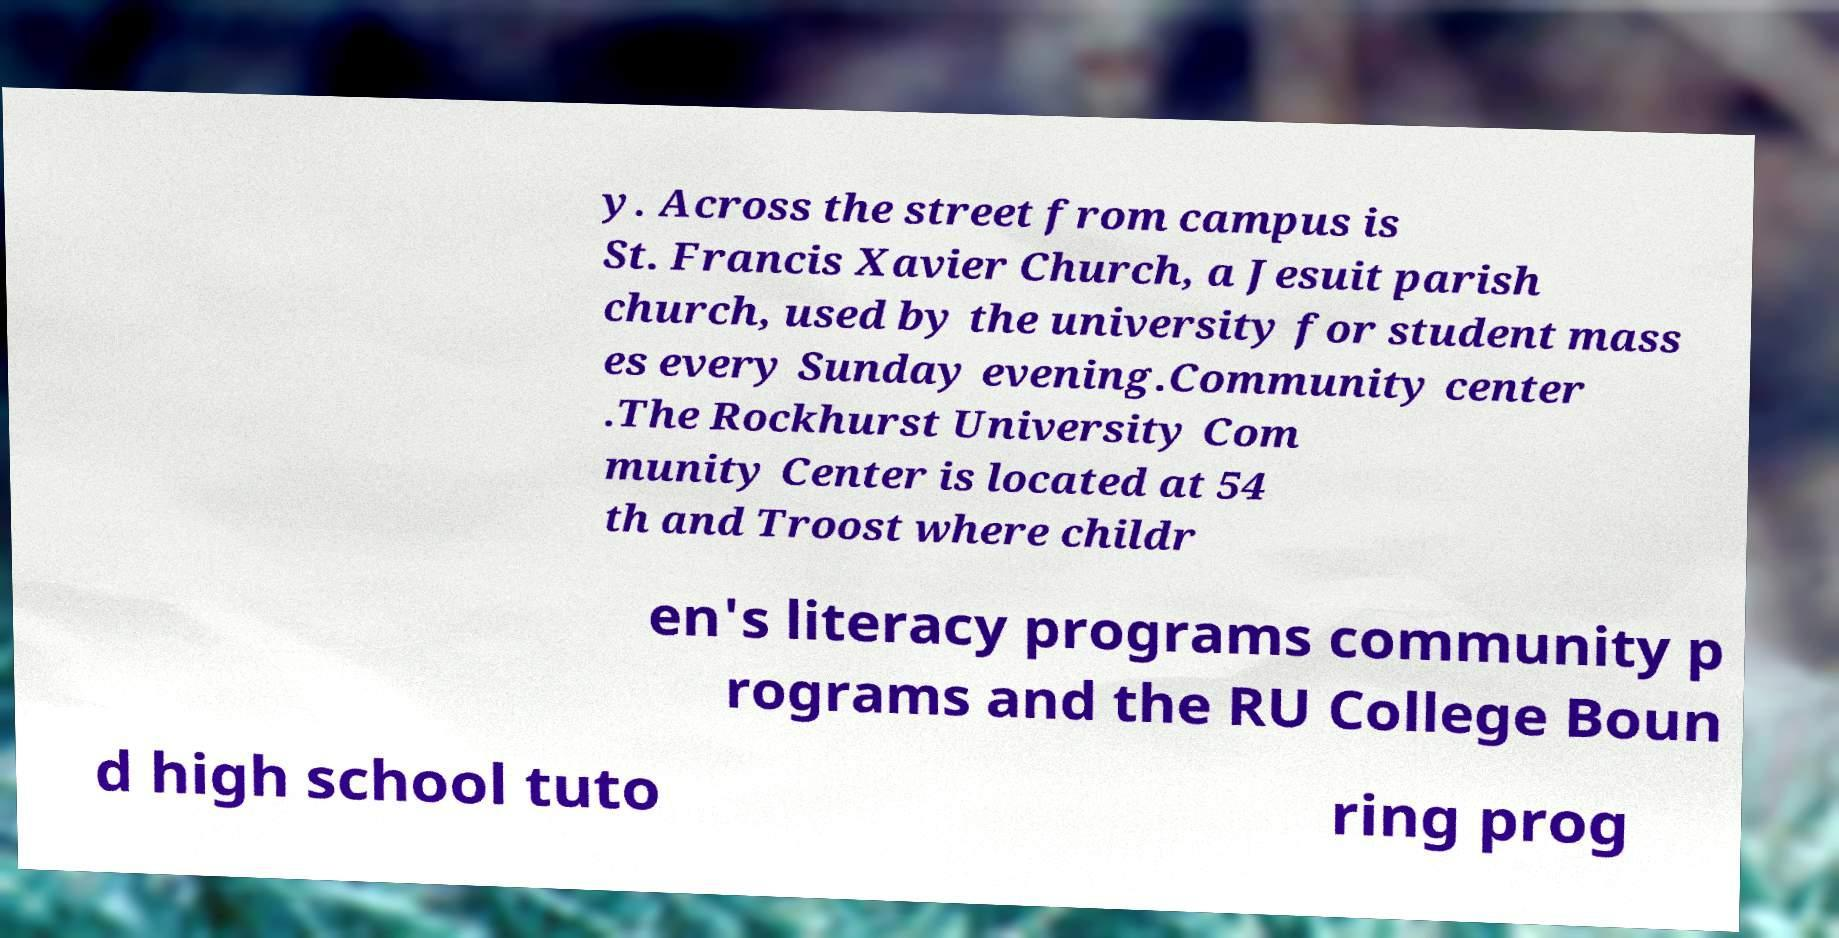There's text embedded in this image that I need extracted. Can you transcribe it verbatim? y. Across the street from campus is St. Francis Xavier Church, a Jesuit parish church, used by the university for student mass es every Sunday evening.Community center .The Rockhurst University Com munity Center is located at 54 th and Troost where childr en's literacy programs community p rograms and the RU College Boun d high school tuto ring prog 